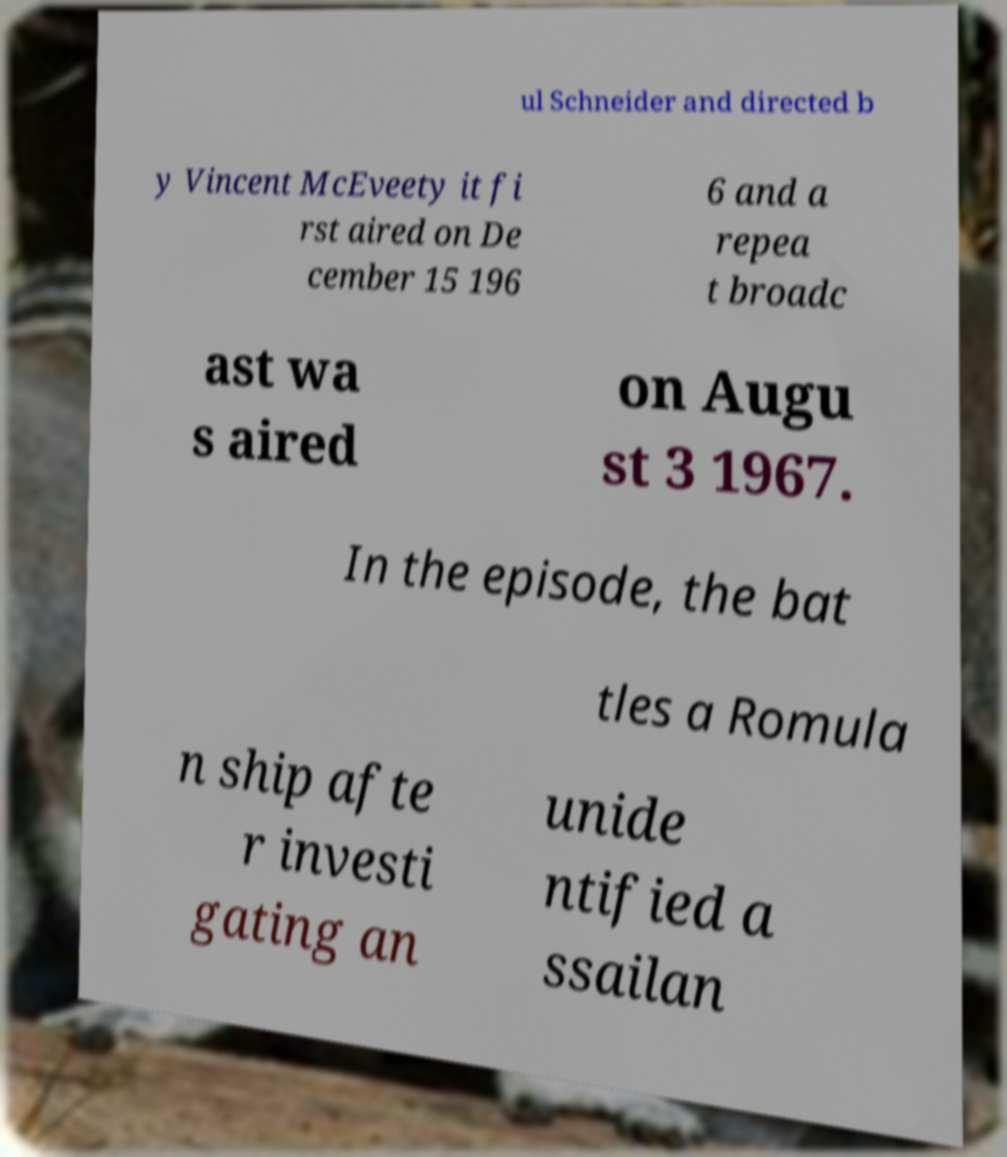Could you extract and type out the text from this image? ul Schneider and directed b y Vincent McEveety it fi rst aired on De cember 15 196 6 and a repea t broadc ast wa s aired on Augu st 3 1967. In the episode, the bat tles a Romula n ship afte r investi gating an unide ntified a ssailan 